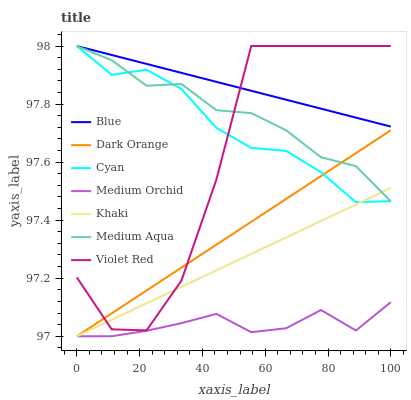Does Medium Orchid have the minimum area under the curve?
Answer yes or no. Yes. Does Blue have the maximum area under the curve?
Answer yes or no. Yes. Does Dark Orange have the minimum area under the curve?
Answer yes or no. No. Does Dark Orange have the maximum area under the curve?
Answer yes or no. No. Is Khaki the smoothest?
Answer yes or no. Yes. Is Violet Red the roughest?
Answer yes or no. Yes. Is Dark Orange the smoothest?
Answer yes or no. No. Is Dark Orange the roughest?
Answer yes or no. No. Does Dark Orange have the lowest value?
Answer yes or no. Yes. Does Violet Red have the lowest value?
Answer yes or no. No. Does Cyan have the highest value?
Answer yes or no. Yes. Does Dark Orange have the highest value?
Answer yes or no. No. Is Dark Orange less than Blue?
Answer yes or no. Yes. Is Blue greater than Medium Orchid?
Answer yes or no. Yes. Does Cyan intersect Medium Aqua?
Answer yes or no. Yes. Is Cyan less than Medium Aqua?
Answer yes or no. No. Is Cyan greater than Medium Aqua?
Answer yes or no. No. Does Dark Orange intersect Blue?
Answer yes or no. No. 